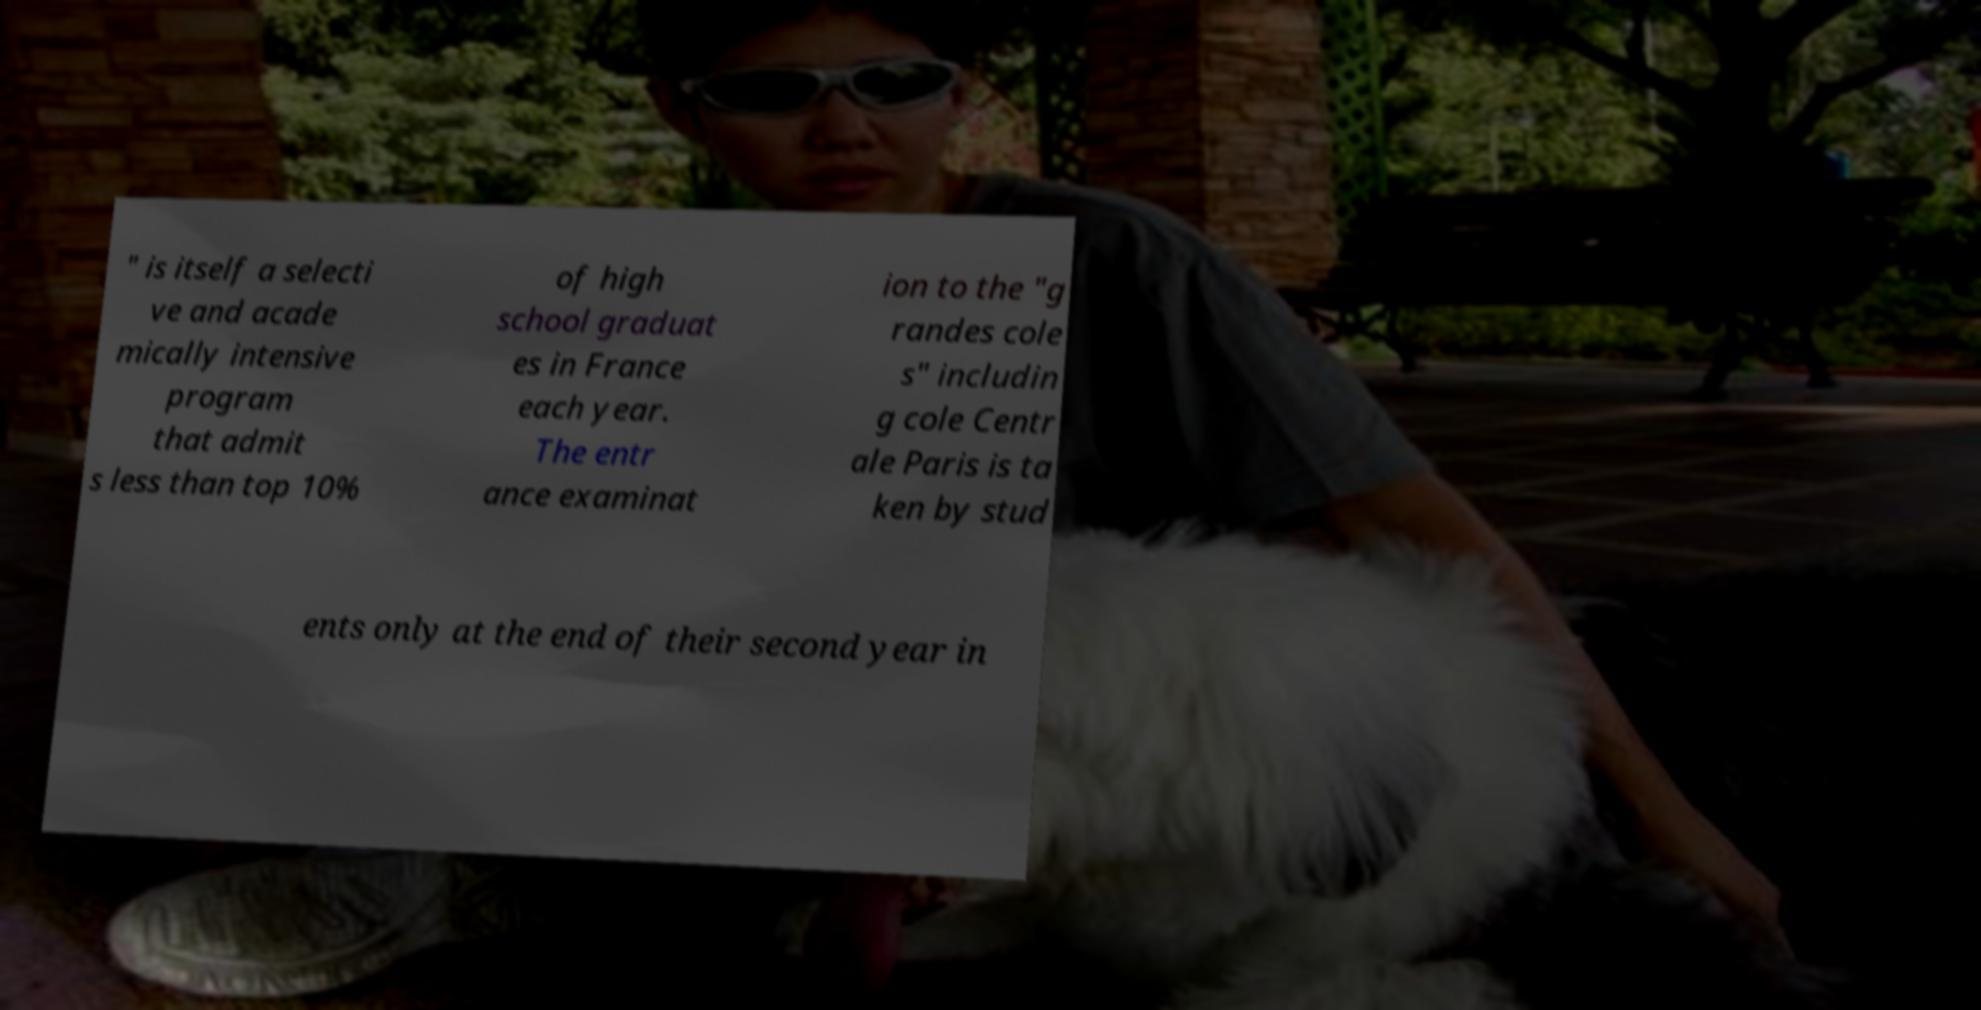What messages or text are displayed in this image? I need them in a readable, typed format. " is itself a selecti ve and acade mically intensive program that admit s less than top 10% of high school graduat es in France each year. The entr ance examinat ion to the "g randes cole s" includin g cole Centr ale Paris is ta ken by stud ents only at the end of their second year in 